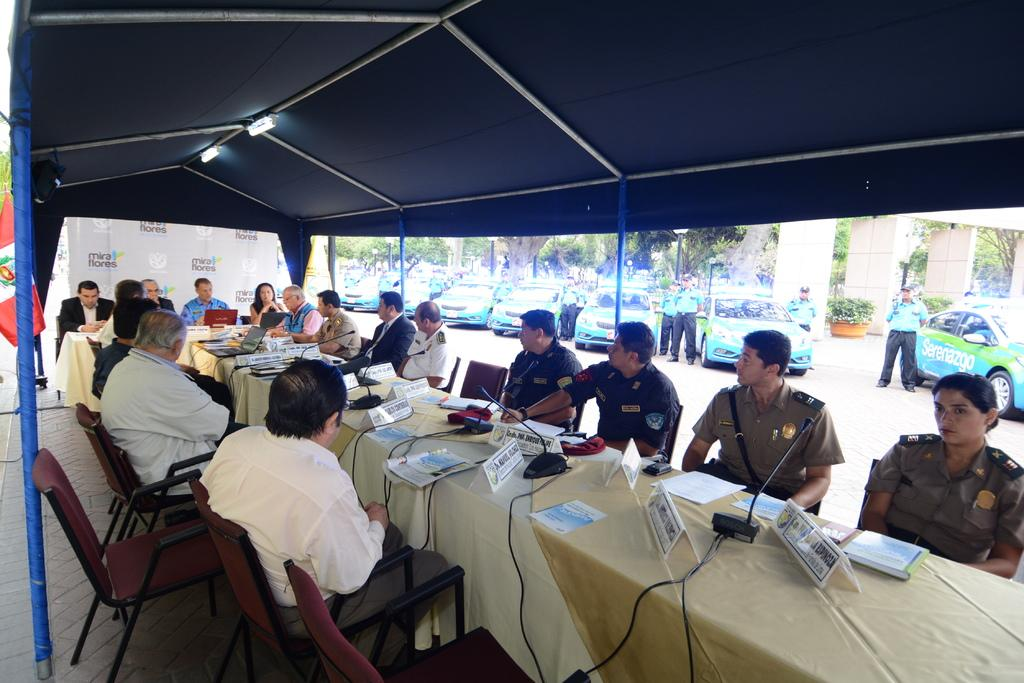What are the people in the image doing? There is a group of people sitting on chairs in the image. What objects can be seen on the table in the image? There is a book, paper, a microphone (mic), and a laptop on the table in the image. What can be seen in the background of the image? Cars and trees are visible at the back side of the image. What type of canvas is being used by the people in the image? There is no canvas present in the image; the people are sitting on chairs. Is there a swing visible in the image? No, there is no swing present in the image. 